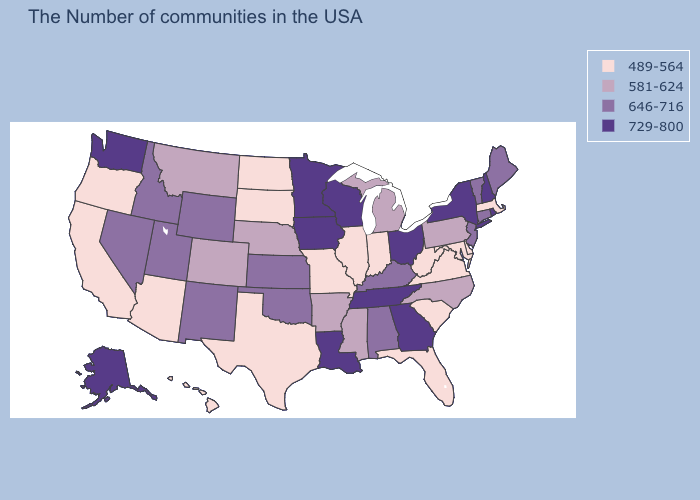Does New Mexico have the same value as Delaware?
Give a very brief answer. No. Does Oregon have a lower value than New Mexico?
Concise answer only. Yes. What is the value of Tennessee?
Short answer required. 729-800. What is the value of Minnesota?
Keep it brief. 729-800. Name the states that have a value in the range 489-564?
Answer briefly. Massachusetts, Delaware, Maryland, Virginia, South Carolina, West Virginia, Florida, Indiana, Illinois, Missouri, Texas, South Dakota, North Dakota, Arizona, California, Oregon, Hawaii. Name the states that have a value in the range 581-624?
Answer briefly. Pennsylvania, North Carolina, Michigan, Mississippi, Arkansas, Nebraska, Colorado, Montana. Name the states that have a value in the range 729-800?
Concise answer only. Rhode Island, New Hampshire, New York, Ohio, Georgia, Tennessee, Wisconsin, Louisiana, Minnesota, Iowa, Washington, Alaska. Among the states that border New York , which have the lowest value?
Write a very short answer. Massachusetts. What is the value of Vermont?
Short answer required. 646-716. What is the value of Alaska?
Give a very brief answer. 729-800. How many symbols are there in the legend?
Concise answer only. 4. Does the map have missing data?
Keep it brief. No. Which states hav the highest value in the West?
Answer briefly. Washington, Alaska. Does Oregon have the highest value in the USA?
Write a very short answer. No. Among the states that border New Hampshire , which have the lowest value?
Give a very brief answer. Massachusetts. 